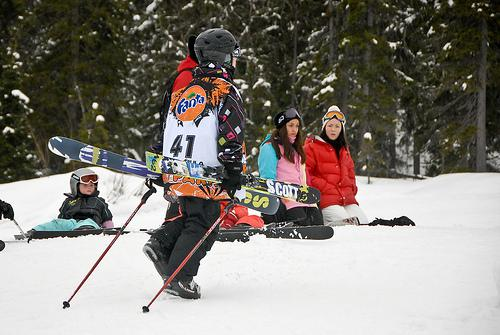Question: where is the snow?
Choices:
A. On the roof.
B. On the ground.
C. Covering the car.
D. On the driveway.
Answer with the letter. Answer: B Question: what soda logo is shown?
Choices:
A. Shasta.
B. Barq's.
C. Pepsi.
D. Fanta.
Answer with the letter. Answer: D Question: how many sticks are shown?
Choices:
A. Three.
B. One.
C. Four.
D. Two.
Answer with the letter. Answer: D Question: why are googles worn?
Choices:
A. To block the wind.
B. To see under water.
C. To protect their eyes.
D. To see in the dark.
Answer with the letter. Answer: C 